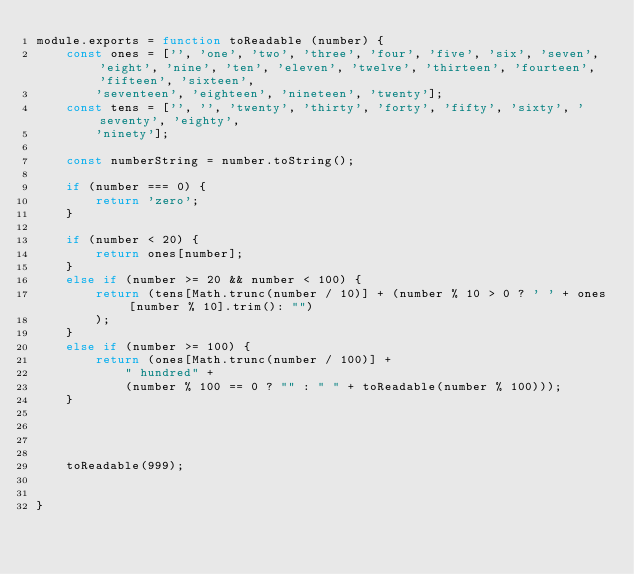Convert code to text. <code><loc_0><loc_0><loc_500><loc_500><_JavaScript_>module.exports = function toReadable (number) {
    const ones = ['', 'one', 'two', 'three', 'four', 'five', 'six', 'seven', 'eight', 'nine', 'ten', 'eleven', 'twelve', 'thirteen', 'fourteen', 'fifteen', 'sixteen',
        'seventeen', 'eighteen', 'nineteen', 'twenty'];
    const tens = ['', '', 'twenty', 'thirty', 'forty', 'fifty', 'sixty', 'seventy', 'eighty',
        'ninety'];
    
    const numberString = number.toString();

    if (number === 0) {
        return 'zero';
    }

    if (number < 20) {
        return ones[number];
    }
    else if (number >= 20 && number < 100) {
        return (tens[Math.trunc(number / 10)] + (number % 10 > 0 ? ' ' + ones[number % 10].trim(): "")
        );
    }
    else if (number >= 100) {
        return (ones[Math.trunc(number / 100)] +
            " hundred" +
            (number % 100 == 0 ? "" : " " + toReadable(number % 100)));
    }




    toReadable(999);

  
}
</code> 